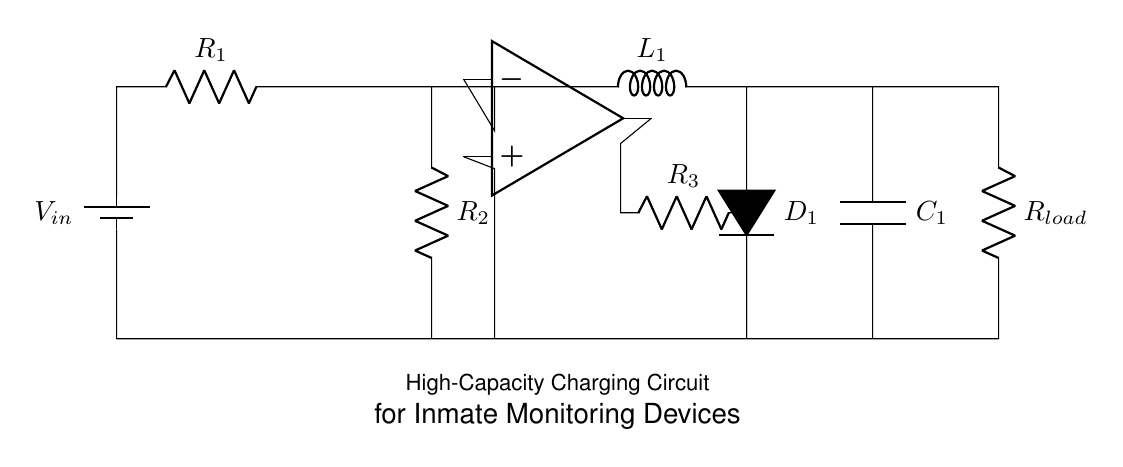What is the input voltage in the circuit? The input voltage is labeled as V_in in the diagram, indicating the voltage source that provides power to the circuit.
Answer: V_in What type of inductor is used in the circuit? The circuit incorporates an inductor labeled L_1, which serves as a component for energy storage.
Answer: L_1 Where does the output current flow? The output current flows through R_load, indicating it's the load component that consumes energy.
Answer: R_load What component is used to control the output voltage? The operational amplifier illustrated in the circuit diagram indicates it is used to control and stabilize the output voltage.
Answer: Op amp How many resistors are present in the circuit? The circuit contains three resistors as denoted by R_1, R_2, and R_3, indicating their roles in limiting current and providing voltage drops.
Answer: 3 Why is the capacitor important in this circuit? The capacitor labeled C_1 is crucial for smoothing out fluctuations in the output voltage and providing stable power to the monitoring devices.
Answer: C_1 How are the components connected in series or parallel? The resistors R_1 and R_2 are connected in series, while R_load is in parallel with the combination of R_1, R_2 and C_1; this creates a balanced distribution of current through the circuit.
Answer: Series and parallel 